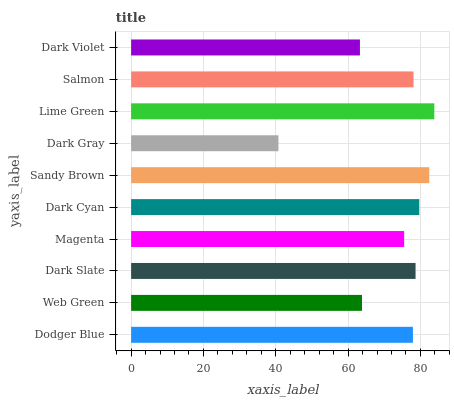Is Dark Gray the minimum?
Answer yes or no. Yes. Is Lime Green the maximum?
Answer yes or no. Yes. Is Web Green the minimum?
Answer yes or no. No. Is Web Green the maximum?
Answer yes or no. No. Is Dodger Blue greater than Web Green?
Answer yes or no. Yes. Is Web Green less than Dodger Blue?
Answer yes or no. Yes. Is Web Green greater than Dodger Blue?
Answer yes or no. No. Is Dodger Blue less than Web Green?
Answer yes or no. No. Is Salmon the high median?
Answer yes or no. Yes. Is Dodger Blue the low median?
Answer yes or no. Yes. Is Dodger Blue the high median?
Answer yes or no. No. Is Magenta the low median?
Answer yes or no. No. 